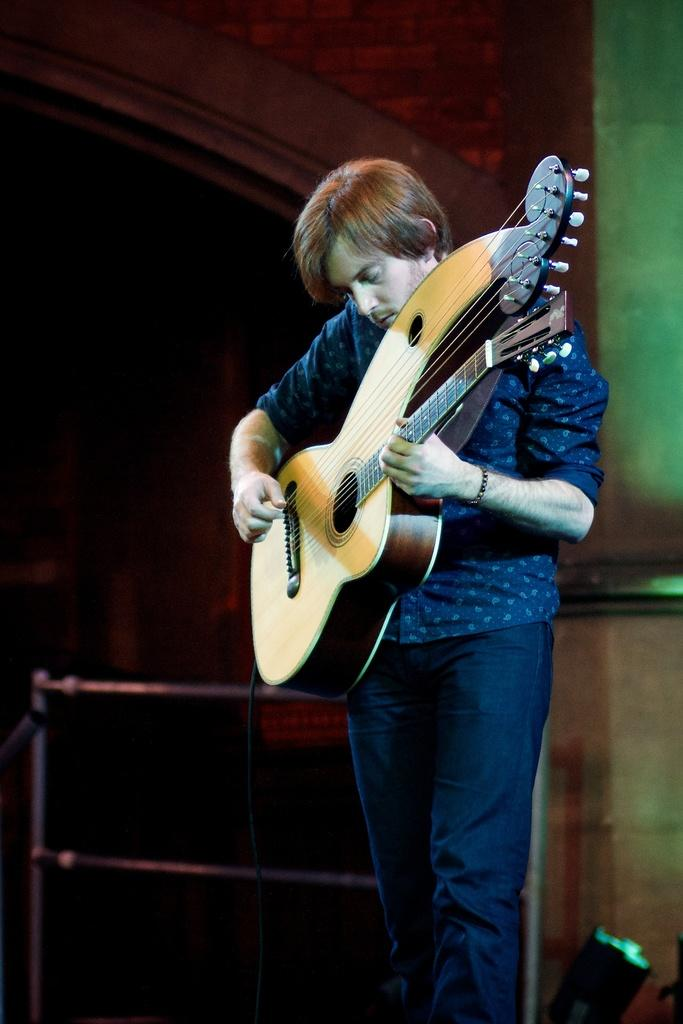What is the man in the image doing? The man is playing a guitar. What is the man wearing on his upper body? The man is wearing a blue color shirt. What type of pants is the man wearing? The man is wearing jeans. What can be seen behind the man? There is a wall and an iron fencing behind the man. What type of vacation is the man planning based on the image? There is no information about a vacation in the image, as it only shows a man playing a guitar. What type of steel is used to make the fencing behind the man? The image does not provide information about the type of steel used in the fencing, only that it is iron fencing. 